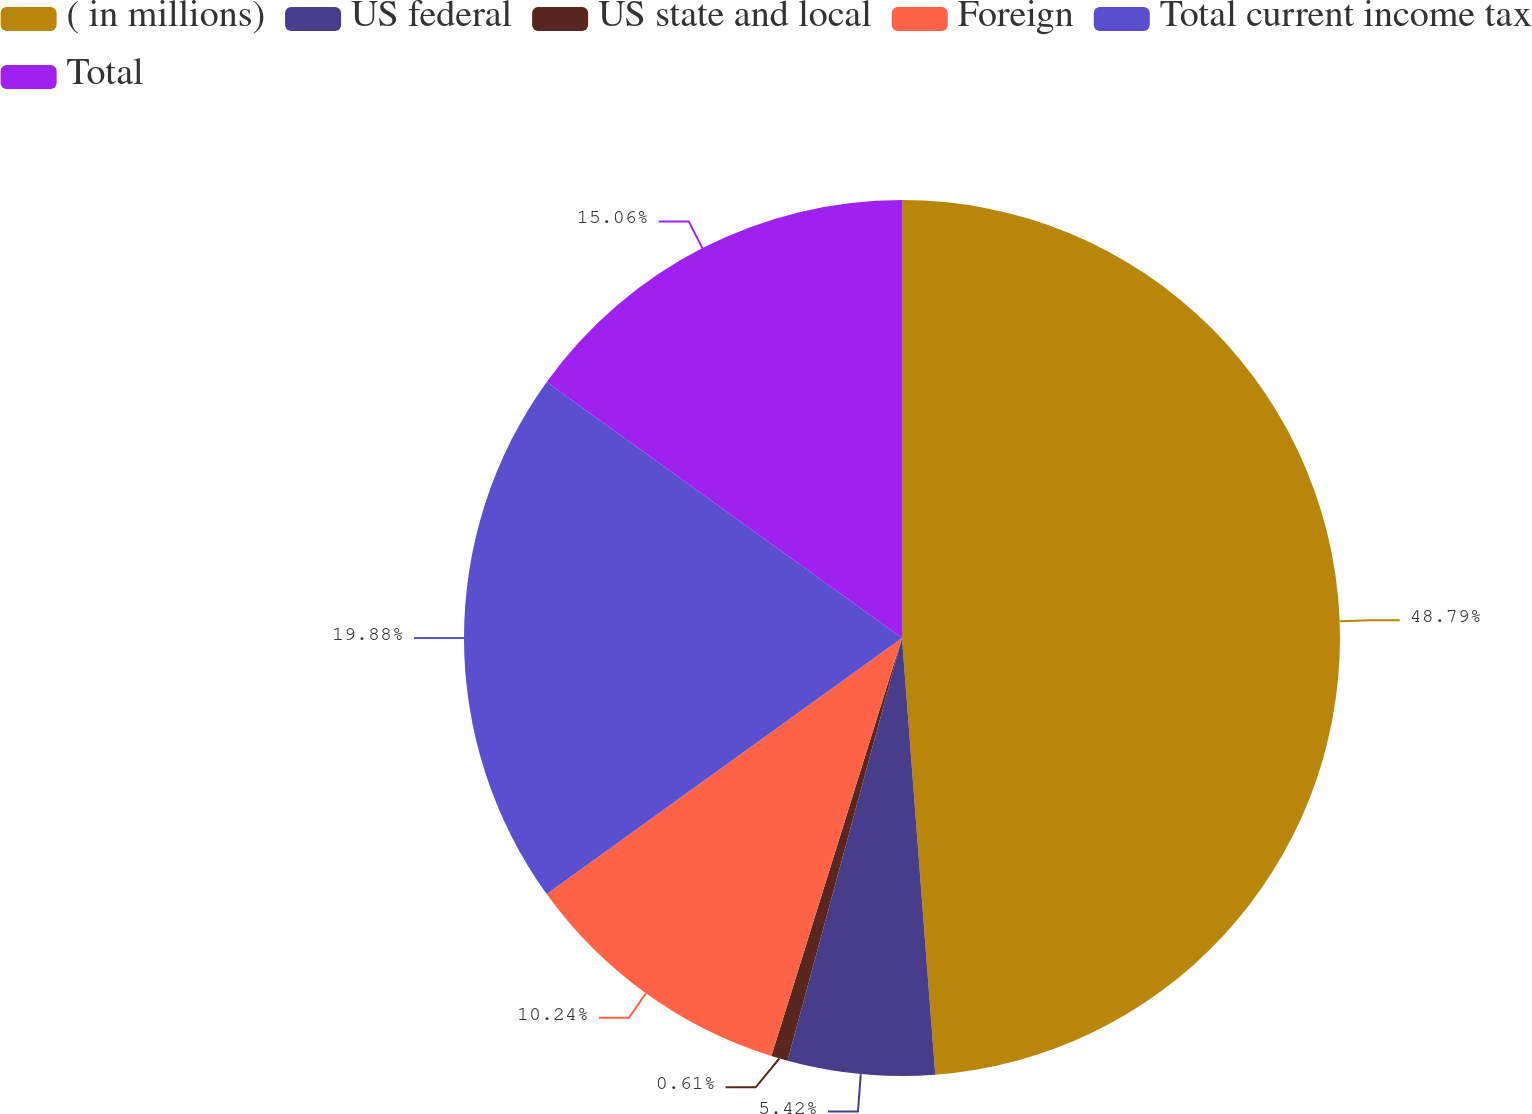Convert chart. <chart><loc_0><loc_0><loc_500><loc_500><pie_chart><fcel>( in millions)<fcel>US federal<fcel>US state and local<fcel>Foreign<fcel>Total current income tax<fcel>Total<nl><fcel>48.79%<fcel>5.42%<fcel>0.61%<fcel>10.24%<fcel>19.88%<fcel>15.06%<nl></chart> 